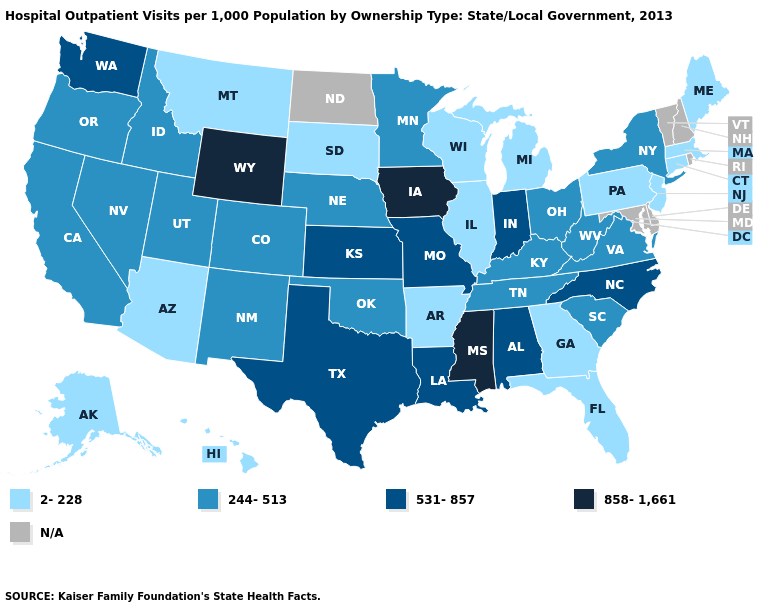Does Iowa have the lowest value in the MidWest?
Answer briefly. No. Is the legend a continuous bar?
Be succinct. No. What is the highest value in states that border New Hampshire?
Answer briefly. 2-228. How many symbols are there in the legend?
Write a very short answer. 5. What is the value of New Hampshire?
Keep it brief. N/A. Is the legend a continuous bar?
Give a very brief answer. No. Does California have the lowest value in the West?
Quick response, please. No. What is the value of Iowa?
Be succinct. 858-1,661. Among the states that border California , does Oregon have the lowest value?
Answer briefly. No. What is the value of Arkansas?
Keep it brief. 2-228. What is the highest value in the USA?
Short answer required. 858-1,661. Does the first symbol in the legend represent the smallest category?
Be succinct. Yes. Which states have the highest value in the USA?
Short answer required. Iowa, Mississippi, Wyoming. 